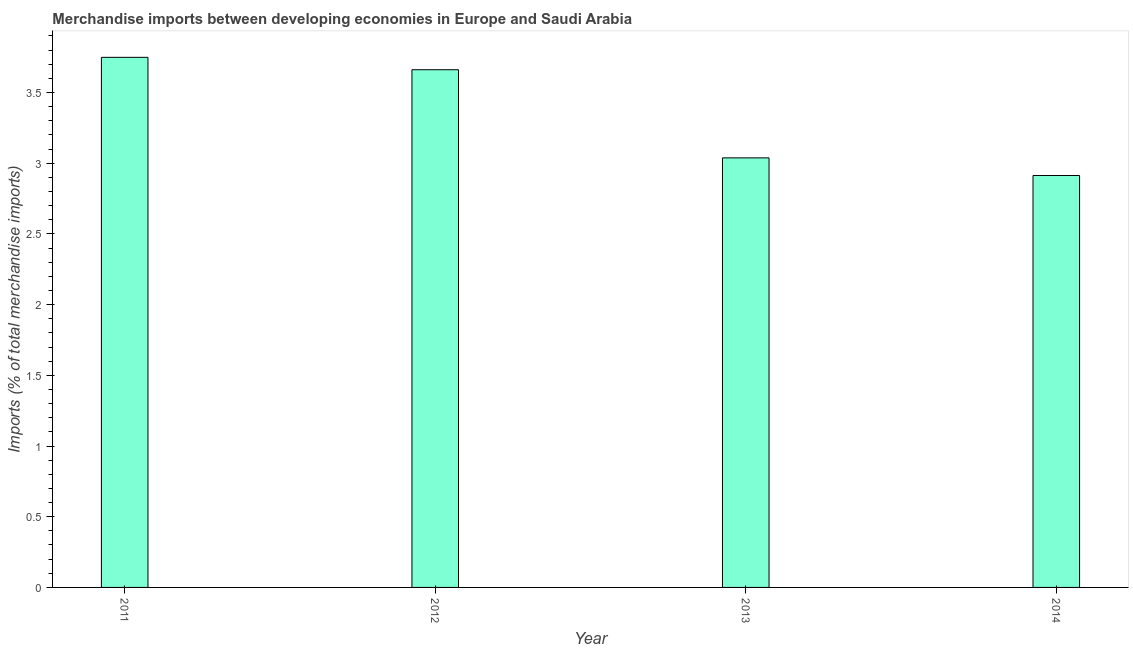What is the title of the graph?
Make the answer very short. Merchandise imports between developing economies in Europe and Saudi Arabia. What is the label or title of the Y-axis?
Make the answer very short. Imports (% of total merchandise imports). What is the merchandise imports in 2014?
Provide a short and direct response. 2.91. Across all years, what is the maximum merchandise imports?
Provide a succinct answer. 3.75. Across all years, what is the minimum merchandise imports?
Ensure brevity in your answer.  2.91. In which year was the merchandise imports maximum?
Offer a terse response. 2011. What is the sum of the merchandise imports?
Make the answer very short. 13.36. What is the difference between the merchandise imports in 2011 and 2014?
Keep it short and to the point. 0.83. What is the average merchandise imports per year?
Give a very brief answer. 3.34. What is the median merchandise imports?
Offer a terse response. 3.35. What is the ratio of the merchandise imports in 2011 to that in 2013?
Give a very brief answer. 1.23. Is the merchandise imports in 2012 less than that in 2013?
Offer a terse response. No. What is the difference between the highest and the second highest merchandise imports?
Ensure brevity in your answer.  0.09. Is the sum of the merchandise imports in 2011 and 2014 greater than the maximum merchandise imports across all years?
Provide a short and direct response. Yes. What is the difference between the highest and the lowest merchandise imports?
Ensure brevity in your answer.  0.84. In how many years, is the merchandise imports greater than the average merchandise imports taken over all years?
Your answer should be very brief. 2. How many bars are there?
Give a very brief answer. 4. Are all the bars in the graph horizontal?
Your answer should be very brief. No. What is the Imports (% of total merchandise imports) in 2011?
Ensure brevity in your answer.  3.75. What is the Imports (% of total merchandise imports) in 2012?
Your response must be concise. 3.66. What is the Imports (% of total merchandise imports) of 2013?
Give a very brief answer. 3.04. What is the Imports (% of total merchandise imports) of 2014?
Offer a very short reply. 2.91. What is the difference between the Imports (% of total merchandise imports) in 2011 and 2012?
Keep it short and to the point. 0.09. What is the difference between the Imports (% of total merchandise imports) in 2011 and 2013?
Your answer should be very brief. 0.71. What is the difference between the Imports (% of total merchandise imports) in 2011 and 2014?
Offer a terse response. 0.84. What is the difference between the Imports (% of total merchandise imports) in 2012 and 2013?
Your response must be concise. 0.62. What is the difference between the Imports (% of total merchandise imports) in 2012 and 2014?
Provide a short and direct response. 0.75. What is the difference between the Imports (% of total merchandise imports) in 2013 and 2014?
Provide a short and direct response. 0.12. What is the ratio of the Imports (% of total merchandise imports) in 2011 to that in 2013?
Make the answer very short. 1.23. What is the ratio of the Imports (% of total merchandise imports) in 2011 to that in 2014?
Your answer should be very brief. 1.29. What is the ratio of the Imports (% of total merchandise imports) in 2012 to that in 2013?
Provide a short and direct response. 1.21. What is the ratio of the Imports (% of total merchandise imports) in 2012 to that in 2014?
Ensure brevity in your answer.  1.26. What is the ratio of the Imports (% of total merchandise imports) in 2013 to that in 2014?
Keep it short and to the point. 1.04. 